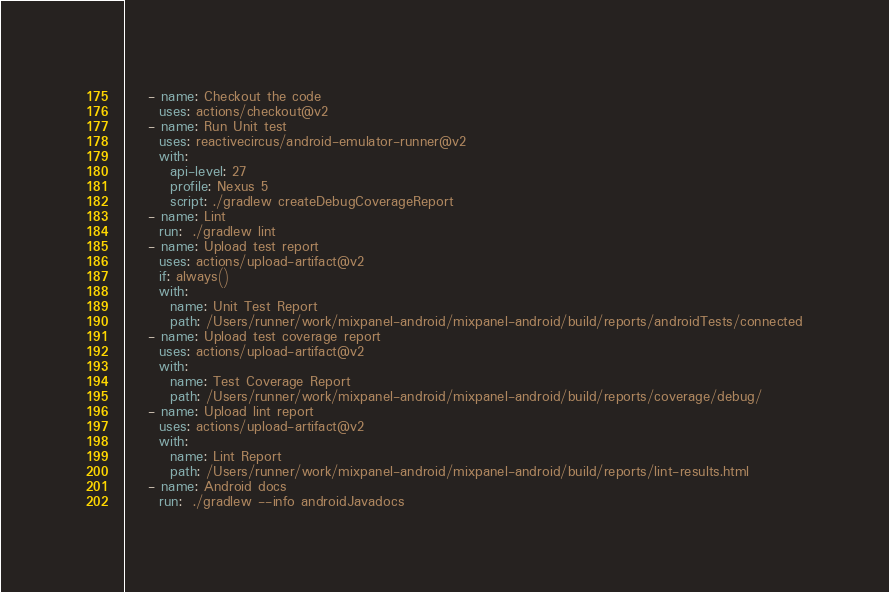Convert code to text. <code><loc_0><loc_0><loc_500><loc_500><_YAML_>    - name: Checkout the code
      uses: actions/checkout@v2
    - name: Run Unit test
      uses: reactivecircus/android-emulator-runner@v2
      with:
        api-level: 27
        profile: Nexus 5
        script: ./gradlew createDebugCoverageReport
    - name: Lint
      run:  ./gradlew lint
    - name: Upload test report
      uses: actions/upload-artifact@v2
      if: always()
      with:
        name: Unit Test Report
        path: /Users/runner/work/mixpanel-android/mixpanel-android/build/reports/androidTests/connected
    - name: Upload test coverage report
      uses: actions/upload-artifact@v2
      with:
        name: Test Coverage Report
        path: /Users/runner/work/mixpanel-android/mixpanel-android/build/reports/coverage/debug/
    - name: Upload lint report
      uses: actions/upload-artifact@v2
      with:
        name: Lint Report
        path: /Users/runner/work/mixpanel-android/mixpanel-android/build/reports/lint-results.html
    - name: Android docs
      run:  ./gradlew --info androidJavadocs

</code> 